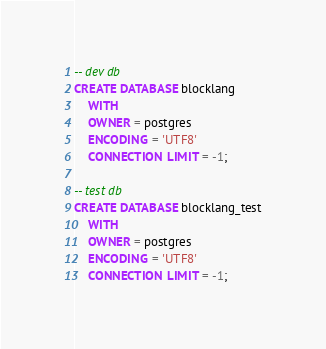Convert code to text. <code><loc_0><loc_0><loc_500><loc_500><_SQL_>-- dev db
CREATE DATABASE blocklang
    WITH 
    OWNER = postgres
    ENCODING = 'UTF8'
    CONNECTION LIMIT = -1;
    
-- test db
CREATE DATABASE blocklang_test
    WITH 
    OWNER = postgres
    ENCODING = 'UTF8'
    CONNECTION LIMIT = -1;</code> 